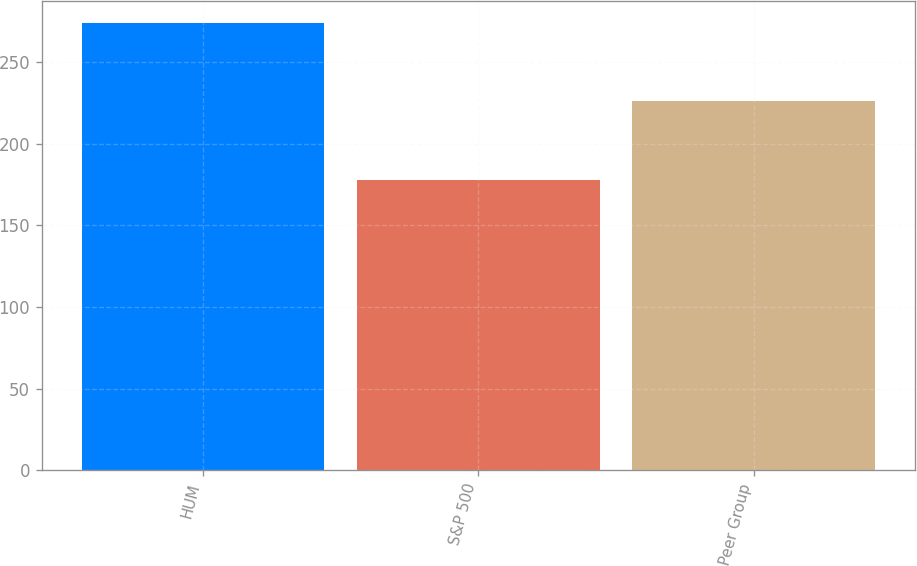Convert chart. <chart><loc_0><loc_0><loc_500><loc_500><bar_chart><fcel>HUM<fcel>S&P 500<fcel>Peer Group<nl><fcel>274<fcel>178<fcel>226<nl></chart> 